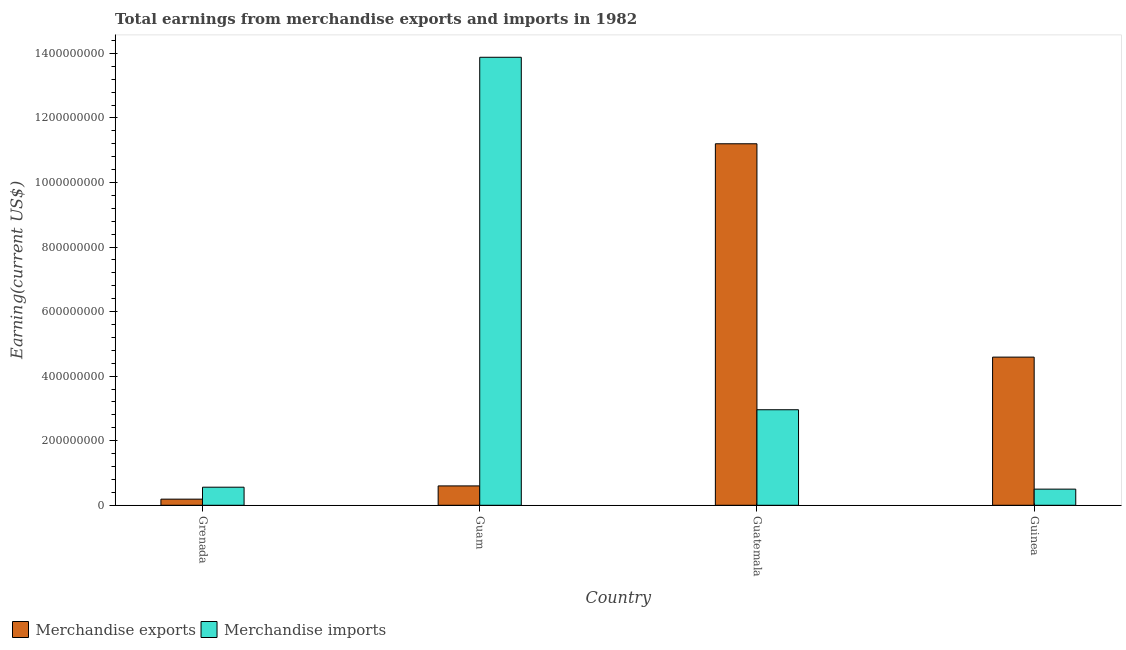Are the number of bars per tick equal to the number of legend labels?
Your answer should be very brief. Yes. How many bars are there on the 1st tick from the left?
Offer a terse response. 2. What is the label of the 3rd group of bars from the left?
Your answer should be compact. Guatemala. In how many cases, is the number of bars for a given country not equal to the number of legend labels?
Provide a succinct answer. 0. What is the earnings from merchandise imports in Guatemala?
Give a very brief answer. 2.96e+08. Across all countries, what is the maximum earnings from merchandise imports?
Keep it short and to the point. 1.39e+09. Across all countries, what is the minimum earnings from merchandise imports?
Offer a very short reply. 5.00e+07. In which country was the earnings from merchandise exports maximum?
Offer a terse response. Guatemala. In which country was the earnings from merchandise exports minimum?
Provide a succinct answer. Grenada. What is the total earnings from merchandise imports in the graph?
Your answer should be very brief. 1.79e+09. What is the difference between the earnings from merchandise imports in Grenada and that in Guam?
Keep it short and to the point. -1.33e+09. What is the difference between the earnings from merchandise exports in Grenada and the earnings from merchandise imports in Guam?
Keep it short and to the point. -1.37e+09. What is the average earnings from merchandise exports per country?
Offer a terse response. 4.14e+08. What is the difference between the earnings from merchandise exports and earnings from merchandise imports in Guinea?
Provide a short and direct response. 4.09e+08. What is the ratio of the earnings from merchandise exports in Grenada to that in Guinea?
Provide a short and direct response. 0.04. What is the difference between the highest and the second highest earnings from merchandise exports?
Make the answer very short. 6.61e+08. What is the difference between the highest and the lowest earnings from merchandise imports?
Keep it short and to the point. 1.34e+09. In how many countries, is the earnings from merchandise exports greater than the average earnings from merchandise exports taken over all countries?
Your answer should be very brief. 2. What does the 2nd bar from the right in Grenada represents?
Offer a very short reply. Merchandise exports. Are all the bars in the graph horizontal?
Ensure brevity in your answer.  No. How many countries are there in the graph?
Your answer should be compact. 4. Are the values on the major ticks of Y-axis written in scientific E-notation?
Your answer should be very brief. No. Does the graph contain any zero values?
Keep it short and to the point. No. How are the legend labels stacked?
Offer a very short reply. Horizontal. What is the title of the graph?
Your response must be concise. Total earnings from merchandise exports and imports in 1982. Does "Females" appear as one of the legend labels in the graph?
Ensure brevity in your answer.  No. What is the label or title of the Y-axis?
Give a very brief answer. Earning(current US$). What is the Earning(current US$) of Merchandise exports in Grenada?
Offer a terse response. 1.90e+07. What is the Earning(current US$) of Merchandise imports in Grenada?
Offer a very short reply. 5.60e+07. What is the Earning(current US$) in Merchandise exports in Guam?
Offer a very short reply. 6.00e+07. What is the Earning(current US$) in Merchandise imports in Guam?
Offer a terse response. 1.39e+09. What is the Earning(current US$) of Merchandise exports in Guatemala?
Provide a short and direct response. 1.12e+09. What is the Earning(current US$) in Merchandise imports in Guatemala?
Offer a very short reply. 2.96e+08. What is the Earning(current US$) in Merchandise exports in Guinea?
Your answer should be compact. 4.59e+08. Across all countries, what is the maximum Earning(current US$) of Merchandise exports?
Provide a succinct answer. 1.12e+09. Across all countries, what is the maximum Earning(current US$) in Merchandise imports?
Provide a short and direct response. 1.39e+09. Across all countries, what is the minimum Earning(current US$) of Merchandise exports?
Keep it short and to the point. 1.90e+07. What is the total Earning(current US$) in Merchandise exports in the graph?
Offer a very short reply. 1.66e+09. What is the total Earning(current US$) in Merchandise imports in the graph?
Offer a terse response. 1.79e+09. What is the difference between the Earning(current US$) in Merchandise exports in Grenada and that in Guam?
Provide a succinct answer. -4.10e+07. What is the difference between the Earning(current US$) of Merchandise imports in Grenada and that in Guam?
Offer a very short reply. -1.33e+09. What is the difference between the Earning(current US$) of Merchandise exports in Grenada and that in Guatemala?
Offer a very short reply. -1.10e+09. What is the difference between the Earning(current US$) in Merchandise imports in Grenada and that in Guatemala?
Your answer should be very brief. -2.40e+08. What is the difference between the Earning(current US$) of Merchandise exports in Grenada and that in Guinea?
Ensure brevity in your answer.  -4.40e+08. What is the difference between the Earning(current US$) of Merchandise imports in Grenada and that in Guinea?
Provide a short and direct response. 6.00e+06. What is the difference between the Earning(current US$) in Merchandise exports in Guam and that in Guatemala?
Offer a very short reply. -1.06e+09. What is the difference between the Earning(current US$) of Merchandise imports in Guam and that in Guatemala?
Ensure brevity in your answer.  1.09e+09. What is the difference between the Earning(current US$) of Merchandise exports in Guam and that in Guinea?
Your answer should be very brief. -3.99e+08. What is the difference between the Earning(current US$) of Merchandise imports in Guam and that in Guinea?
Give a very brief answer. 1.34e+09. What is the difference between the Earning(current US$) in Merchandise exports in Guatemala and that in Guinea?
Your response must be concise. 6.61e+08. What is the difference between the Earning(current US$) in Merchandise imports in Guatemala and that in Guinea?
Ensure brevity in your answer.  2.46e+08. What is the difference between the Earning(current US$) of Merchandise exports in Grenada and the Earning(current US$) of Merchandise imports in Guam?
Offer a very short reply. -1.37e+09. What is the difference between the Earning(current US$) in Merchandise exports in Grenada and the Earning(current US$) in Merchandise imports in Guatemala?
Make the answer very short. -2.77e+08. What is the difference between the Earning(current US$) of Merchandise exports in Grenada and the Earning(current US$) of Merchandise imports in Guinea?
Your answer should be very brief. -3.10e+07. What is the difference between the Earning(current US$) in Merchandise exports in Guam and the Earning(current US$) in Merchandise imports in Guatemala?
Your answer should be compact. -2.36e+08. What is the difference between the Earning(current US$) in Merchandise exports in Guam and the Earning(current US$) in Merchandise imports in Guinea?
Offer a terse response. 1.00e+07. What is the difference between the Earning(current US$) of Merchandise exports in Guatemala and the Earning(current US$) of Merchandise imports in Guinea?
Your answer should be compact. 1.07e+09. What is the average Earning(current US$) of Merchandise exports per country?
Offer a very short reply. 4.14e+08. What is the average Earning(current US$) of Merchandise imports per country?
Provide a short and direct response. 4.48e+08. What is the difference between the Earning(current US$) of Merchandise exports and Earning(current US$) of Merchandise imports in Grenada?
Make the answer very short. -3.70e+07. What is the difference between the Earning(current US$) of Merchandise exports and Earning(current US$) of Merchandise imports in Guam?
Give a very brief answer. -1.33e+09. What is the difference between the Earning(current US$) in Merchandise exports and Earning(current US$) in Merchandise imports in Guatemala?
Offer a terse response. 8.24e+08. What is the difference between the Earning(current US$) of Merchandise exports and Earning(current US$) of Merchandise imports in Guinea?
Provide a succinct answer. 4.09e+08. What is the ratio of the Earning(current US$) in Merchandise exports in Grenada to that in Guam?
Offer a terse response. 0.32. What is the ratio of the Earning(current US$) of Merchandise imports in Grenada to that in Guam?
Your response must be concise. 0.04. What is the ratio of the Earning(current US$) of Merchandise exports in Grenada to that in Guatemala?
Provide a succinct answer. 0.02. What is the ratio of the Earning(current US$) of Merchandise imports in Grenada to that in Guatemala?
Keep it short and to the point. 0.19. What is the ratio of the Earning(current US$) in Merchandise exports in Grenada to that in Guinea?
Your response must be concise. 0.04. What is the ratio of the Earning(current US$) in Merchandise imports in Grenada to that in Guinea?
Your answer should be very brief. 1.12. What is the ratio of the Earning(current US$) in Merchandise exports in Guam to that in Guatemala?
Provide a short and direct response. 0.05. What is the ratio of the Earning(current US$) of Merchandise imports in Guam to that in Guatemala?
Your response must be concise. 4.69. What is the ratio of the Earning(current US$) of Merchandise exports in Guam to that in Guinea?
Provide a succinct answer. 0.13. What is the ratio of the Earning(current US$) of Merchandise imports in Guam to that in Guinea?
Your answer should be very brief. 27.76. What is the ratio of the Earning(current US$) in Merchandise exports in Guatemala to that in Guinea?
Provide a succinct answer. 2.44. What is the ratio of the Earning(current US$) in Merchandise imports in Guatemala to that in Guinea?
Give a very brief answer. 5.92. What is the difference between the highest and the second highest Earning(current US$) in Merchandise exports?
Your response must be concise. 6.61e+08. What is the difference between the highest and the second highest Earning(current US$) of Merchandise imports?
Provide a succinct answer. 1.09e+09. What is the difference between the highest and the lowest Earning(current US$) in Merchandise exports?
Provide a short and direct response. 1.10e+09. What is the difference between the highest and the lowest Earning(current US$) of Merchandise imports?
Provide a short and direct response. 1.34e+09. 